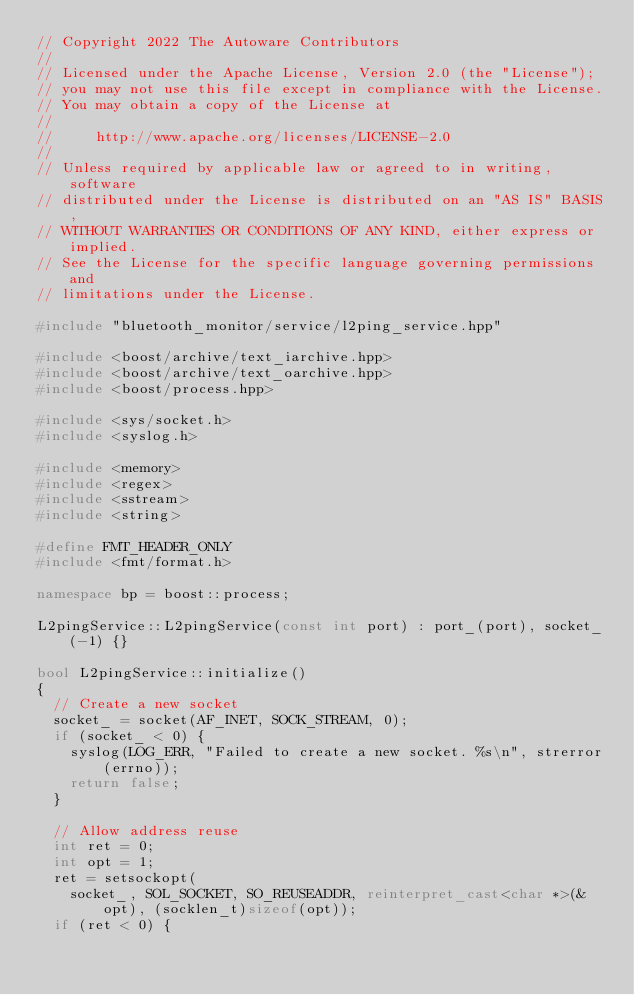Convert code to text. <code><loc_0><loc_0><loc_500><loc_500><_C++_>// Copyright 2022 The Autoware Contributors
//
// Licensed under the Apache License, Version 2.0 (the "License");
// you may not use this file except in compliance with the License.
// You may obtain a copy of the License at
//
//     http://www.apache.org/licenses/LICENSE-2.0
//
// Unless required by applicable law or agreed to in writing, software
// distributed under the License is distributed on an "AS IS" BASIS,
// WITHOUT WARRANTIES OR CONDITIONS OF ANY KIND, either express or implied.
// See the License for the specific language governing permissions and
// limitations under the License.

#include "bluetooth_monitor/service/l2ping_service.hpp"

#include <boost/archive/text_iarchive.hpp>
#include <boost/archive/text_oarchive.hpp>
#include <boost/process.hpp>

#include <sys/socket.h>
#include <syslog.h>

#include <memory>
#include <regex>
#include <sstream>
#include <string>

#define FMT_HEADER_ONLY
#include <fmt/format.h>

namespace bp = boost::process;

L2pingService::L2pingService(const int port) : port_(port), socket_(-1) {}

bool L2pingService::initialize()
{
  // Create a new socket
  socket_ = socket(AF_INET, SOCK_STREAM, 0);
  if (socket_ < 0) {
    syslog(LOG_ERR, "Failed to create a new socket. %s\n", strerror(errno));
    return false;
  }

  // Allow address reuse
  int ret = 0;
  int opt = 1;
  ret = setsockopt(
    socket_, SOL_SOCKET, SO_REUSEADDR, reinterpret_cast<char *>(&opt), (socklen_t)sizeof(opt));
  if (ret < 0) {</code> 